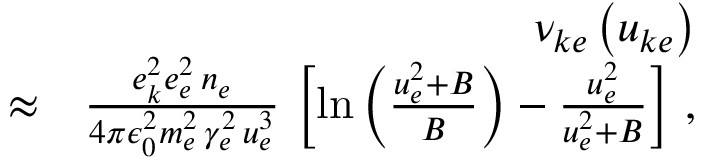Convert formula to latex. <formula><loc_0><loc_0><loc_500><loc_500>\begin{array} { r l r } & { \nu _ { k e } \left ( u _ { k e } \right ) } \\ & { \approx } & { \frac { e _ { k } ^ { 2 } e _ { e } ^ { 2 } \, n _ { e } } { 4 \pi \epsilon _ { 0 } ^ { 2 } m _ { e } ^ { 2 } \, \gamma _ { e } ^ { 2 } \, u _ { e } ^ { 3 } } \, \left [ \ln \left ( \frac { u _ { e } ^ { 2 } + B } { B } \right ) - \frac { u _ { e } ^ { 2 } } { u _ { e } ^ { 2 } + B } \right ] \, , } \end{array}</formula> 